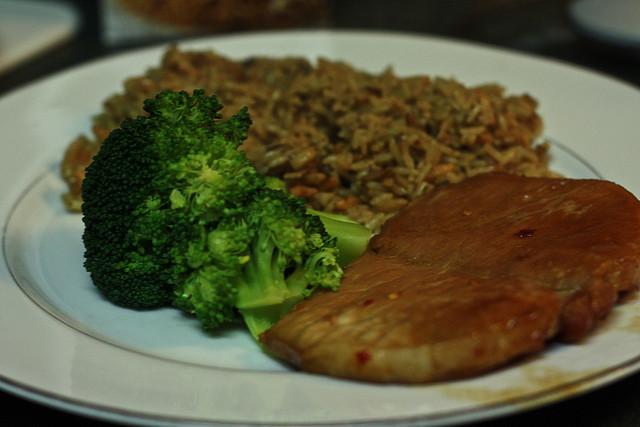Is the food mostly brown?
Keep it brief. Yes. Is there broccoli?
Answer briefly. Yes. How many different kinds of food are there?
Keep it brief. 3. What food is on the plate?
Short answer required. Meat. What are the brown things on the right?
Keep it brief. Steak. Is this a hamburger?
Keep it brief. No. Is there something to drink with this meal?
Write a very short answer. No. What kind of meat is on the plate?
Concise answer only. Pork. What is next to the broccoli?
Concise answer only. Rice. 